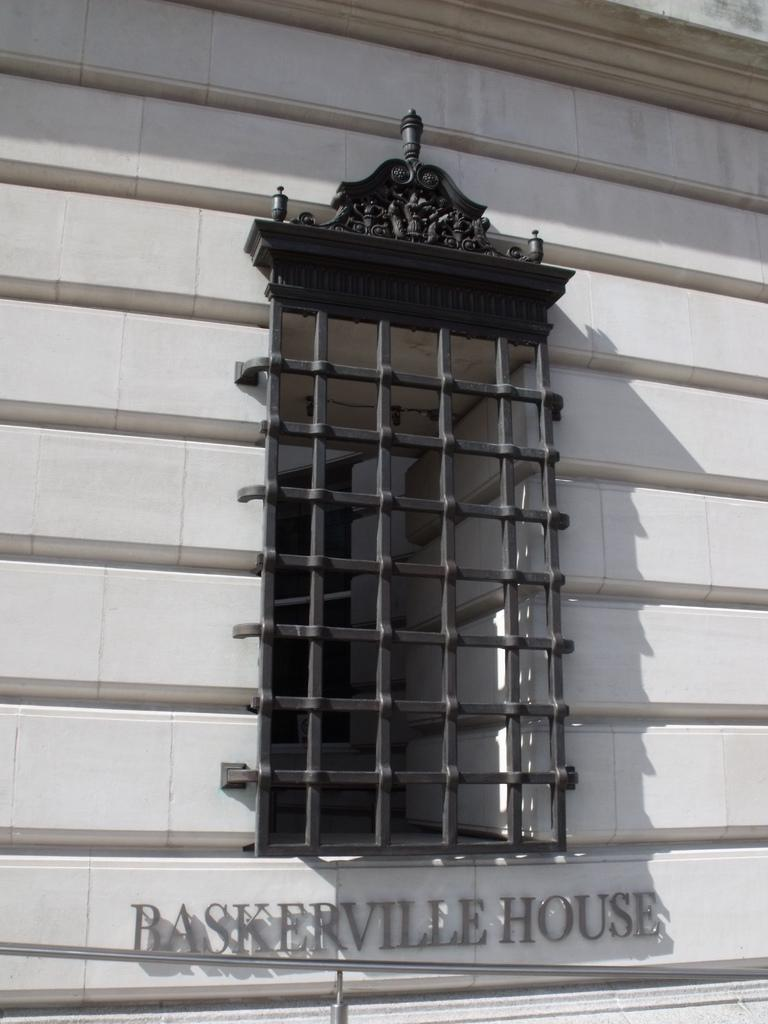What type of structure can be seen in the image? There is a wall in the image. Is there any opening in the wall? Yes, there is a window in the image. What is written or depicted on the wall? There is text on the wall in the image. How is the distribution of matches being organized in the image? There is no mention of matches in the image, so we cannot discuss their distribution. 